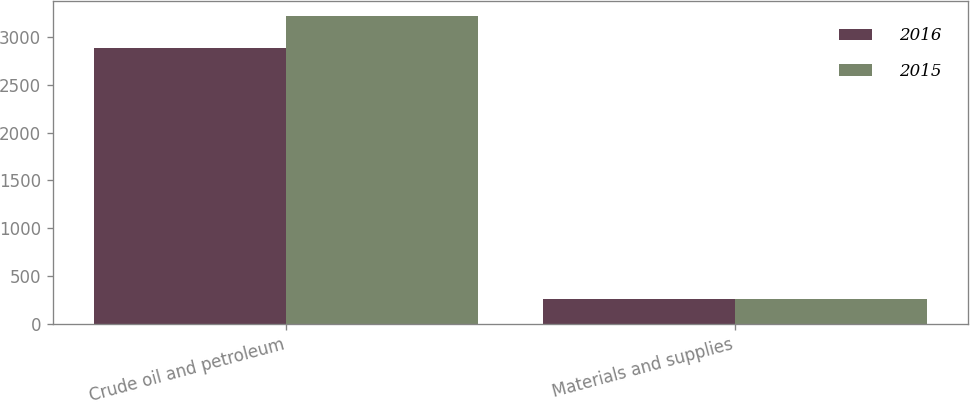<chart> <loc_0><loc_0><loc_500><loc_500><stacked_bar_chart><ecel><fcel>Crude oil and petroleum<fcel>Materials and supplies<nl><fcel>2016<fcel>2883<fcel>267<nl><fcel>2015<fcel>3214<fcel>263<nl></chart> 